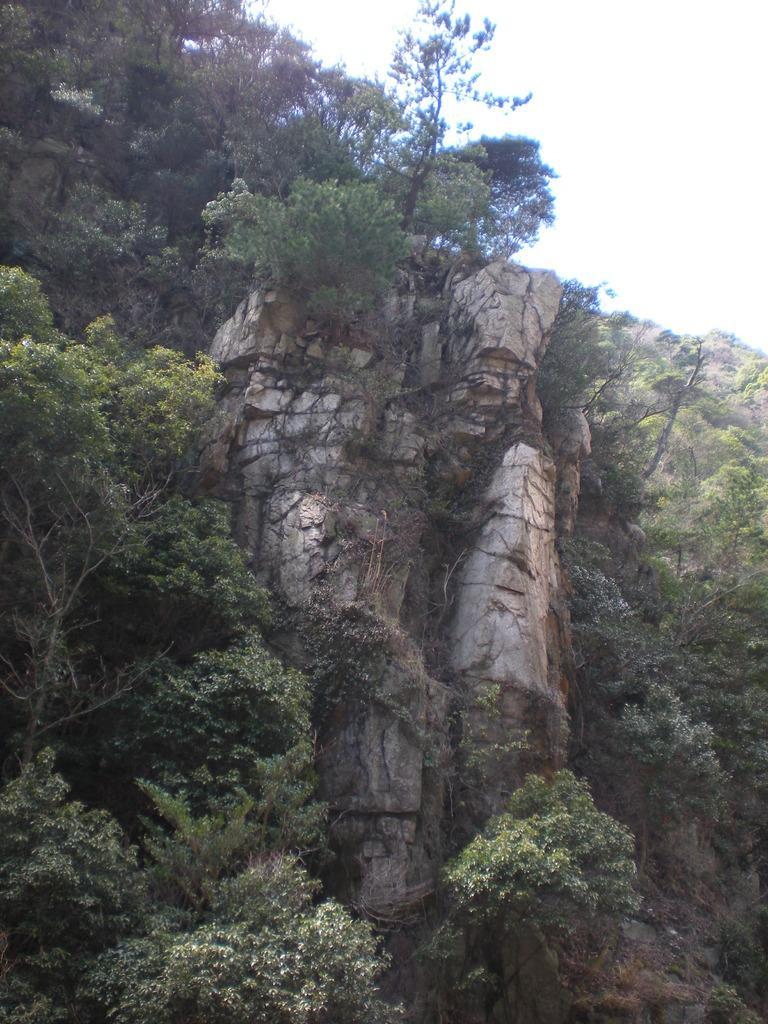In one or two sentences, can you explain what this image depicts? This picture shows hill and we see bunch of trees and a rock and we see a cloudy sky. 